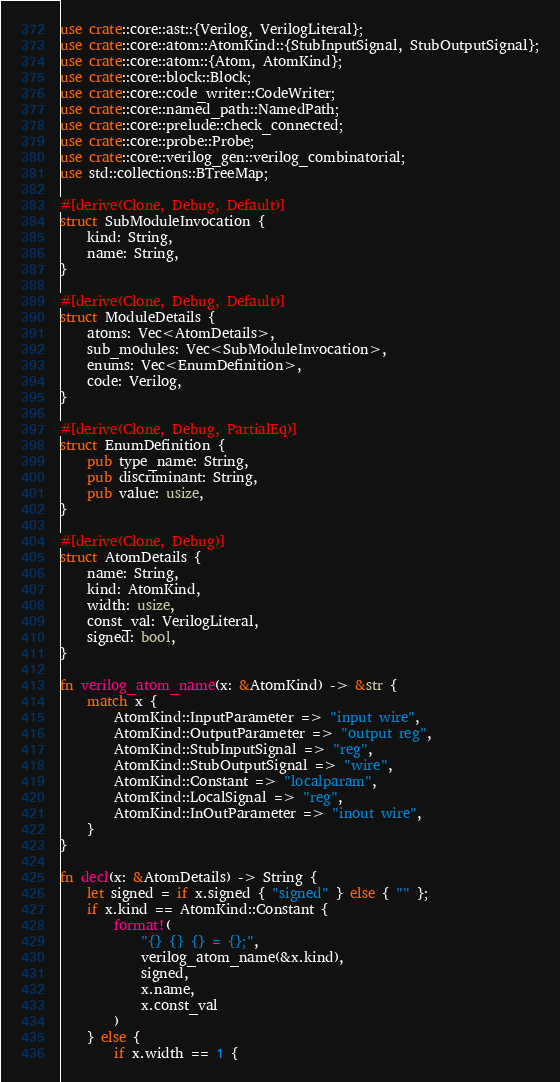Convert code to text. <code><loc_0><loc_0><loc_500><loc_500><_Rust_>use crate::core::ast::{Verilog, VerilogLiteral};
use crate::core::atom::AtomKind::{StubInputSignal, StubOutputSignal};
use crate::core::atom::{Atom, AtomKind};
use crate::core::block::Block;
use crate::core::code_writer::CodeWriter;
use crate::core::named_path::NamedPath;
use crate::core::prelude::check_connected;
use crate::core::probe::Probe;
use crate::core::verilog_gen::verilog_combinatorial;
use std::collections::BTreeMap;

#[derive(Clone, Debug, Default)]
struct SubModuleInvocation {
    kind: String,
    name: String,
}

#[derive(Clone, Debug, Default)]
struct ModuleDetails {
    atoms: Vec<AtomDetails>,
    sub_modules: Vec<SubModuleInvocation>,
    enums: Vec<EnumDefinition>,
    code: Verilog,
}

#[derive(Clone, Debug, PartialEq)]
struct EnumDefinition {
    pub type_name: String,
    pub discriminant: String,
    pub value: usize,
}

#[derive(Clone, Debug)]
struct AtomDetails {
    name: String,
    kind: AtomKind,
    width: usize,
    const_val: VerilogLiteral,
    signed: bool,
}

fn verilog_atom_name(x: &AtomKind) -> &str {
    match x {
        AtomKind::InputParameter => "input wire",
        AtomKind::OutputParameter => "output reg",
        AtomKind::StubInputSignal => "reg",
        AtomKind::StubOutputSignal => "wire",
        AtomKind::Constant => "localparam",
        AtomKind::LocalSignal => "reg",
        AtomKind::InOutParameter => "inout wire",
    }
}

fn decl(x: &AtomDetails) -> String {
    let signed = if x.signed { "signed" } else { "" };
    if x.kind == AtomKind::Constant {
        format!(
            "{} {} {} = {};",
            verilog_atom_name(&x.kind),
            signed,
            x.name,
            x.const_val
        )
    } else {
        if x.width == 1 {</code> 